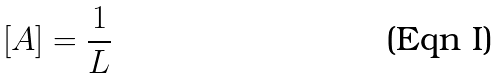<formula> <loc_0><loc_0><loc_500><loc_500>\left [ A \right ] = \frac { 1 } { L }</formula> 